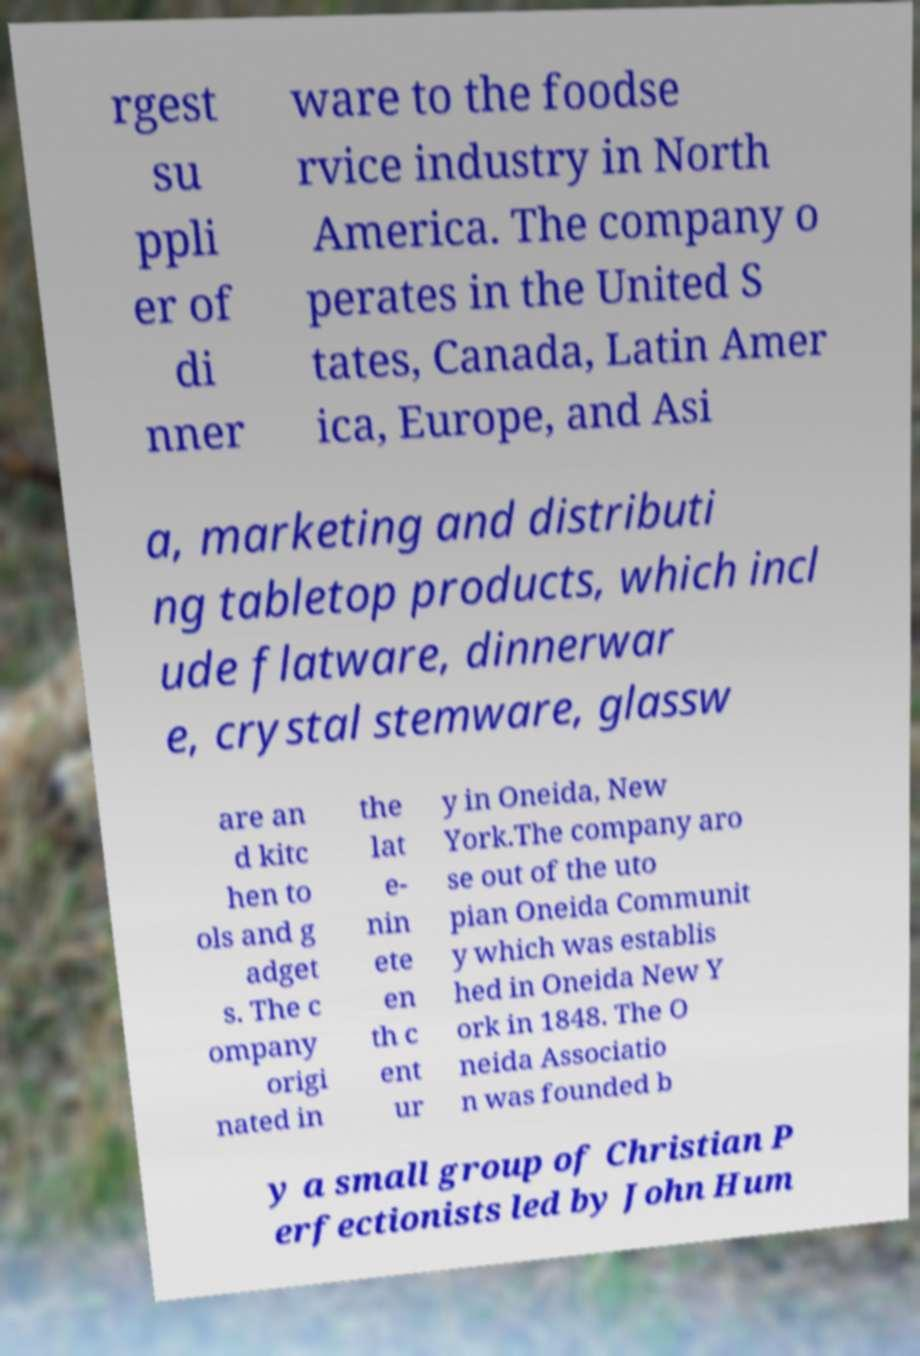Could you assist in decoding the text presented in this image and type it out clearly? rgest su ppli er of di nner ware to the foodse rvice industry in North America. The company o perates in the United S tates, Canada, Latin Amer ica, Europe, and Asi a, marketing and distributi ng tabletop products, which incl ude flatware, dinnerwar e, crystal stemware, glassw are an d kitc hen to ols and g adget s. The c ompany origi nated in the lat e- nin ete en th c ent ur y in Oneida, New York.The company aro se out of the uto pian Oneida Communit y which was establis hed in Oneida New Y ork in 1848. The O neida Associatio n was founded b y a small group of Christian P erfectionists led by John Hum 